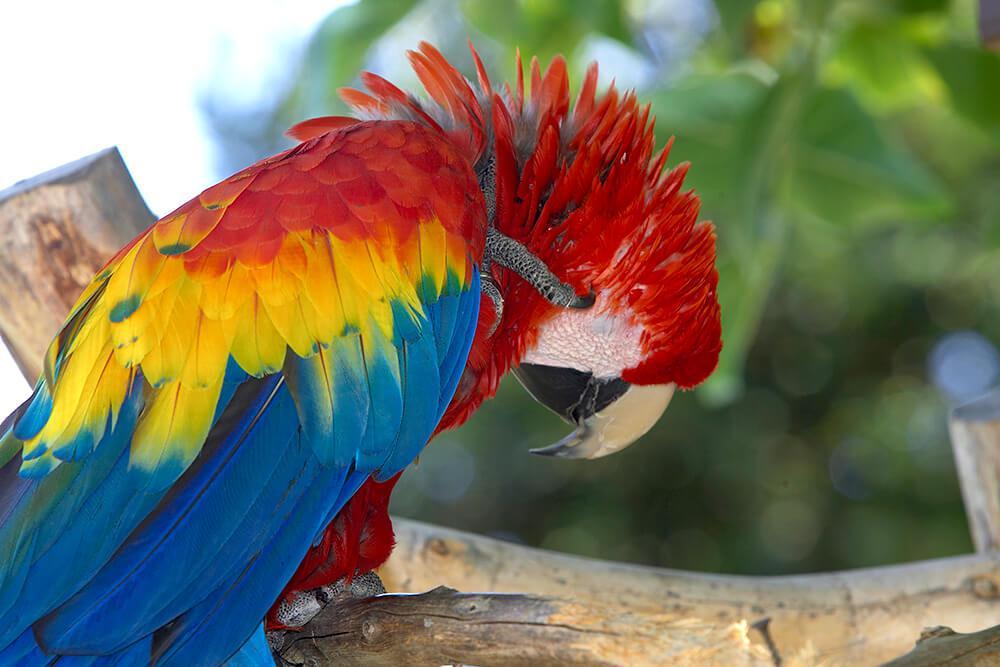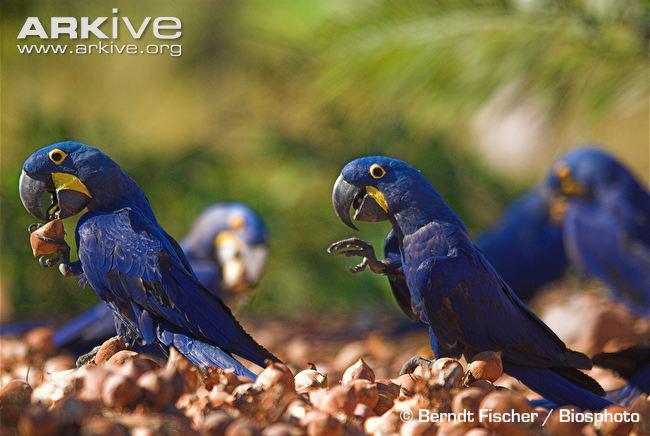The first image is the image on the left, the second image is the image on the right. Evaluate the accuracy of this statement regarding the images: "An image contains one red-headed parrot facing rightward, and the other image contains blue-headed birds.". Is it true? Answer yes or no. Yes. The first image is the image on the left, the second image is the image on the right. Given the left and right images, does the statement "There are at least two blue parrots in the right image." hold true? Answer yes or no. Yes. 